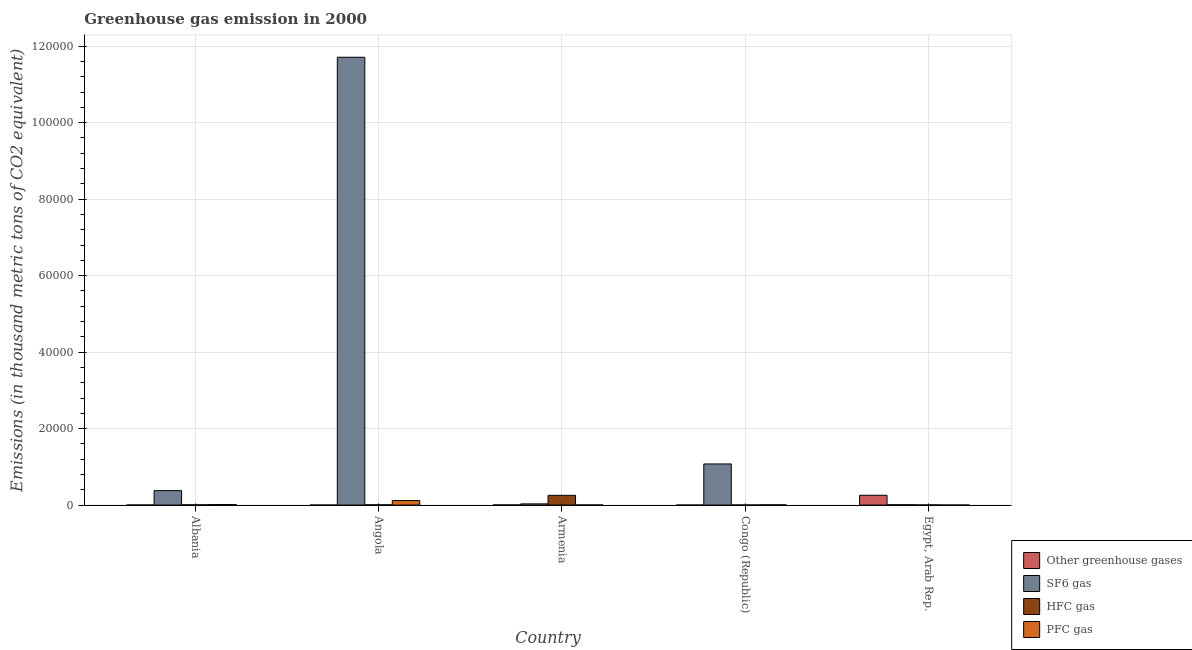Are the number of bars per tick equal to the number of legend labels?
Offer a very short reply. Yes. Are the number of bars on each tick of the X-axis equal?
Offer a terse response. Yes. How many bars are there on the 1st tick from the left?
Your answer should be very brief. 4. What is the label of the 5th group of bars from the left?
Your response must be concise. Egypt, Arab Rep. In how many cases, is the number of bars for a given country not equal to the number of legend labels?
Give a very brief answer. 0. What is the emission of sf6 gas in Armenia?
Offer a very short reply. 311.4. Across all countries, what is the maximum emission of pfc gas?
Provide a succinct answer. 1181.4. Across all countries, what is the minimum emission of sf6 gas?
Offer a terse response. 81.4. In which country was the emission of hfc gas maximum?
Your answer should be compact. Armenia. In which country was the emission of sf6 gas minimum?
Give a very brief answer. Egypt, Arab Rep. What is the total emission of greenhouse gases in the graph?
Offer a very short reply. 2624.6. What is the difference between the emission of greenhouse gases in Angola and that in Egypt, Arab Rep.?
Offer a very short reply. -2564.9. What is the difference between the emission of greenhouse gases in Armenia and the emission of sf6 gas in Egypt, Arab Rep.?
Provide a short and direct response. -39.4. What is the average emission of greenhouse gases per country?
Keep it short and to the point. 524.92. What is the difference between the emission of greenhouse gases and emission of pfc gas in Armenia?
Your answer should be compact. 9.2. What is the ratio of the emission of hfc gas in Albania to that in Armenia?
Keep it short and to the point. 0.02. What is the difference between the highest and the second highest emission of pfc gas?
Offer a very short reply. 1059.6. What is the difference between the highest and the lowest emission of sf6 gas?
Ensure brevity in your answer.  1.17e+05. Is the sum of the emission of hfc gas in Angola and Congo (Republic) greater than the maximum emission of sf6 gas across all countries?
Keep it short and to the point. No. What does the 4th bar from the left in Angola represents?
Make the answer very short. PFC gas. What does the 4th bar from the right in Congo (Republic) represents?
Make the answer very short. Other greenhouse gases. What is the difference between two consecutive major ticks on the Y-axis?
Offer a very short reply. 2.00e+04. Does the graph contain grids?
Your answer should be very brief. Yes. How many legend labels are there?
Make the answer very short. 4. What is the title of the graph?
Keep it short and to the point. Greenhouse gas emission in 2000. Does "Plant species" appear as one of the legend labels in the graph?
Keep it short and to the point. No. What is the label or title of the Y-axis?
Give a very brief answer. Emissions (in thousand metric tons of CO2 equivalent). What is the Emissions (in thousand metric tons of CO2 equivalent) of SF6 gas in Albania?
Provide a short and direct response. 3781.9. What is the Emissions (in thousand metric tons of CO2 equivalent) of HFC gas in Albania?
Give a very brief answer. 60.5. What is the Emissions (in thousand metric tons of CO2 equivalent) in PFC gas in Albania?
Your answer should be compact. 121.8. What is the Emissions (in thousand metric tons of CO2 equivalent) in SF6 gas in Angola?
Provide a short and direct response. 1.17e+05. What is the Emissions (in thousand metric tons of CO2 equivalent) of PFC gas in Angola?
Give a very brief answer. 1181.4. What is the Emissions (in thousand metric tons of CO2 equivalent) in Other greenhouse gases in Armenia?
Offer a very short reply. 42. What is the Emissions (in thousand metric tons of CO2 equivalent) in SF6 gas in Armenia?
Offer a very short reply. 311.4. What is the Emissions (in thousand metric tons of CO2 equivalent) of HFC gas in Armenia?
Offer a terse response. 2545.7. What is the Emissions (in thousand metric tons of CO2 equivalent) of PFC gas in Armenia?
Provide a short and direct response. 32.8. What is the Emissions (in thousand metric tons of CO2 equivalent) in Other greenhouse gases in Congo (Republic)?
Provide a succinct answer. 0.8. What is the Emissions (in thousand metric tons of CO2 equivalent) in SF6 gas in Congo (Republic)?
Make the answer very short. 1.08e+04. What is the Emissions (in thousand metric tons of CO2 equivalent) of HFC gas in Congo (Republic)?
Offer a very short reply. 25.2. What is the Emissions (in thousand metric tons of CO2 equivalent) of Other greenhouse gases in Egypt, Arab Rep.?
Keep it short and to the point. 2565.6. What is the Emissions (in thousand metric tons of CO2 equivalent) of SF6 gas in Egypt, Arab Rep.?
Offer a terse response. 81.4. What is the Emissions (in thousand metric tons of CO2 equivalent) of HFC gas in Egypt, Arab Rep.?
Your answer should be very brief. 41.4. What is the Emissions (in thousand metric tons of CO2 equivalent) in PFC gas in Egypt, Arab Rep.?
Make the answer very short. 3.5. Across all countries, what is the maximum Emissions (in thousand metric tons of CO2 equivalent) in Other greenhouse gases?
Ensure brevity in your answer.  2565.6. Across all countries, what is the maximum Emissions (in thousand metric tons of CO2 equivalent) in SF6 gas?
Offer a terse response. 1.17e+05. Across all countries, what is the maximum Emissions (in thousand metric tons of CO2 equivalent) of HFC gas?
Offer a terse response. 2545.7. Across all countries, what is the maximum Emissions (in thousand metric tons of CO2 equivalent) in PFC gas?
Keep it short and to the point. 1181.4. Across all countries, what is the minimum Emissions (in thousand metric tons of CO2 equivalent) of SF6 gas?
Offer a very short reply. 81.4. Across all countries, what is the minimum Emissions (in thousand metric tons of CO2 equivalent) of HFC gas?
Provide a succinct answer. 25.2. What is the total Emissions (in thousand metric tons of CO2 equivalent) in Other greenhouse gases in the graph?
Keep it short and to the point. 2624.6. What is the total Emissions (in thousand metric tons of CO2 equivalent) in SF6 gas in the graph?
Provide a succinct answer. 1.32e+05. What is the total Emissions (in thousand metric tons of CO2 equivalent) of HFC gas in the graph?
Provide a succinct answer. 2735.8. What is the total Emissions (in thousand metric tons of CO2 equivalent) in PFC gas in the graph?
Make the answer very short. 1402.5. What is the difference between the Emissions (in thousand metric tons of CO2 equivalent) of SF6 gas in Albania and that in Angola?
Your answer should be very brief. -1.13e+05. What is the difference between the Emissions (in thousand metric tons of CO2 equivalent) in PFC gas in Albania and that in Angola?
Make the answer very short. -1059.6. What is the difference between the Emissions (in thousand metric tons of CO2 equivalent) of Other greenhouse gases in Albania and that in Armenia?
Give a very brief answer. -26.5. What is the difference between the Emissions (in thousand metric tons of CO2 equivalent) in SF6 gas in Albania and that in Armenia?
Offer a very short reply. 3470.5. What is the difference between the Emissions (in thousand metric tons of CO2 equivalent) of HFC gas in Albania and that in Armenia?
Keep it short and to the point. -2485.2. What is the difference between the Emissions (in thousand metric tons of CO2 equivalent) of PFC gas in Albania and that in Armenia?
Keep it short and to the point. 89. What is the difference between the Emissions (in thousand metric tons of CO2 equivalent) of SF6 gas in Albania and that in Congo (Republic)?
Offer a very short reply. -6971.7. What is the difference between the Emissions (in thousand metric tons of CO2 equivalent) of HFC gas in Albania and that in Congo (Republic)?
Offer a terse response. 35.3. What is the difference between the Emissions (in thousand metric tons of CO2 equivalent) of PFC gas in Albania and that in Congo (Republic)?
Offer a terse response. 58.8. What is the difference between the Emissions (in thousand metric tons of CO2 equivalent) in Other greenhouse gases in Albania and that in Egypt, Arab Rep.?
Provide a succinct answer. -2550.1. What is the difference between the Emissions (in thousand metric tons of CO2 equivalent) of SF6 gas in Albania and that in Egypt, Arab Rep.?
Keep it short and to the point. 3700.5. What is the difference between the Emissions (in thousand metric tons of CO2 equivalent) of HFC gas in Albania and that in Egypt, Arab Rep.?
Offer a terse response. 19.1. What is the difference between the Emissions (in thousand metric tons of CO2 equivalent) of PFC gas in Albania and that in Egypt, Arab Rep.?
Your answer should be very brief. 118.3. What is the difference between the Emissions (in thousand metric tons of CO2 equivalent) of Other greenhouse gases in Angola and that in Armenia?
Give a very brief answer. -41.3. What is the difference between the Emissions (in thousand metric tons of CO2 equivalent) of SF6 gas in Angola and that in Armenia?
Your answer should be very brief. 1.17e+05. What is the difference between the Emissions (in thousand metric tons of CO2 equivalent) in HFC gas in Angola and that in Armenia?
Provide a short and direct response. -2482.7. What is the difference between the Emissions (in thousand metric tons of CO2 equivalent) of PFC gas in Angola and that in Armenia?
Your answer should be compact. 1148.6. What is the difference between the Emissions (in thousand metric tons of CO2 equivalent) of Other greenhouse gases in Angola and that in Congo (Republic)?
Offer a terse response. -0.1. What is the difference between the Emissions (in thousand metric tons of CO2 equivalent) in SF6 gas in Angola and that in Congo (Republic)?
Make the answer very short. 1.06e+05. What is the difference between the Emissions (in thousand metric tons of CO2 equivalent) of HFC gas in Angola and that in Congo (Republic)?
Keep it short and to the point. 37.8. What is the difference between the Emissions (in thousand metric tons of CO2 equivalent) in PFC gas in Angola and that in Congo (Republic)?
Ensure brevity in your answer.  1118.4. What is the difference between the Emissions (in thousand metric tons of CO2 equivalent) of Other greenhouse gases in Angola and that in Egypt, Arab Rep.?
Keep it short and to the point. -2564.9. What is the difference between the Emissions (in thousand metric tons of CO2 equivalent) in SF6 gas in Angola and that in Egypt, Arab Rep.?
Offer a very short reply. 1.17e+05. What is the difference between the Emissions (in thousand metric tons of CO2 equivalent) in HFC gas in Angola and that in Egypt, Arab Rep.?
Provide a short and direct response. 21.6. What is the difference between the Emissions (in thousand metric tons of CO2 equivalent) in PFC gas in Angola and that in Egypt, Arab Rep.?
Your answer should be compact. 1177.9. What is the difference between the Emissions (in thousand metric tons of CO2 equivalent) in Other greenhouse gases in Armenia and that in Congo (Republic)?
Keep it short and to the point. 41.2. What is the difference between the Emissions (in thousand metric tons of CO2 equivalent) of SF6 gas in Armenia and that in Congo (Republic)?
Your answer should be compact. -1.04e+04. What is the difference between the Emissions (in thousand metric tons of CO2 equivalent) of HFC gas in Armenia and that in Congo (Republic)?
Ensure brevity in your answer.  2520.5. What is the difference between the Emissions (in thousand metric tons of CO2 equivalent) of PFC gas in Armenia and that in Congo (Republic)?
Give a very brief answer. -30.2. What is the difference between the Emissions (in thousand metric tons of CO2 equivalent) of Other greenhouse gases in Armenia and that in Egypt, Arab Rep.?
Make the answer very short. -2523.6. What is the difference between the Emissions (in thousand metric tons of CO2 equivalent) in SF6 gas in Armenia and that in Egypt, Arab Rep.?
Your answer should be compact. 230. What is the difference between the Emissions (in thousand metric tons of CO2 equivalent) of HFC gas in Armenia and that in Egypt, Arab Rep.?
Ensure brevity in your answer.  2504.3. What is the difference between the Emissions (in thousand metric tons of CO2 equivalent) in PFC gas in Armenia and that in Egypt, Arab Rep.?
Provide a succinct answer. 29.3. What is the difference between the Emissions (in thousand metric tons of CO2 equivalent) in Other greenhouse gases in Congo (Republic) and that in Egypt, Arab Rep.?
Provide a short and direct response. -2564.8. What is the difference between the Emissions (in thousand metric tons of CO2 equivalent) of SF6 gas in Congo (Republic) and that in Egypt, Arab Rep.?
Keep it short and to the point. 1.07e+04. What is the difference between the Emissions (in thousand metric tons of CO2 equivalent) of HFC gas in Congo (Republic) and that in Egypt, Arab Rep.?
Offer a very short reply. -16.2. What is the difference between the Emissions (in thousand metric tons of CO2 equivalent) in PFC gas in Congo (Republic) and that in Egypt, Arab Rep.?
Make the answer very short. 59.5. What is the difference between the Emissions (in thousand metric tons of CO2 equivalent) of Other greenhouse gases in Albania and the Emissions (in thousand metric tons of CO2 equivalent) of SF6 gas in Angola?
Your answer should be compact. -1.17e+05. What is the difference between the Emissions (in thousand metric tons of CO2 equivalent) in Other greenhouse gases in Albania and the Emissions (in thousand metric tons of CO2 equivalent) in HFC gas in Angola?
Make the answer very short. -47.5. What is the difference between the Emissions (in thousand metric tons of CO2 equivalent) of Other greenhouse gases in Albania and the Emissions (in thousand metric tons of CO2 equivalent) of PFC gas in Angola?
Your answer should be very brief. -1165.9. What is the difference between the Emissions (in thousand metric tons of CO2 equivalent) of SF6 gas in Albania and the Emissions (in thousand metric tons of CO2 equivalent) of HFC gas in Angola?
Provide a short and direct response. 3718.9. What is the difference between the Emissions (in thousand metric tons of CO2 equivalent) of SF6 gas in Albania and the Emissions (in thousand metric tons of CO2 equivalent) of PFC gas in Angola?
Provide a short and direct response. 2600.5. What is the difference between the Emissions (in thousand metric tons of CO2 equivalent) of HFC gas in Albania and the Emissions (in thousand metric tons of CO2 equivalent) of PFC gas in Angola?
Provide a short and direct response. -1120.9. What is the difference between the Emissions (in thousand metric tons of CO2 equivalent) of Other greenhouse gases in Albania and the Emissions (in thousand metric tons of CO2 equivalent) of SF6 gas in Armenia?
Your answer should be compact. -295.9. What is the difference between the Emissions (in thousand metric tons of CO2 equivalent) of Other greenhouse gases in Albania and the Emissions (in thousand metric tons of CO2 equivalent) of HFC gas in Armenia?
Give a very brief answer. -2530.2. What is the difference between the Emissions (in thousand metric tons of CO2 equivalent) in Other greenhouse gases in Albania and the Emissions (in thousand metric tons of CO2 equivalent) in PFC gas in Armenia?
Provide a short and direct response. -17.3. What is the difference between the Emissions (in thousand metric tons of CO2 equivalent) of SF6 gas in Albania and the Emissions (in thousand metric tons of CO2 equivalent) of HFC gas in Armenia?
Your answer should be compact. 1236.2. What is the difference between the Emissions (in thousand metric tons of CO2 equivalent) of SF6 gas in Albania and the Emissions (in thousand metric tons of CO2 equivalent) of PFC gas in Armenia?
Provide a short and direct response. 3749.1. What is the difference between the Emissions (in thousand metric tons of CO2 equivalent) in HFC gas in Albania and the Emissions (in thousand metric tons of CO2 equivalent) in PFC gas in Armenia?
Offer a terse response. 27.7. What is the difference between the Emissions (in thousand metric tons of CO2 equivalent) of Other greenhouse gases in Albania and the Emissions (in thousand metric tons of CO2 equivalent) of SF6 gas in Congo (Republic)?
Your answer should be compact. -1.07e+04. What is the difference between the Emissions (in thousand metric tons of CO2 equivalent) in Other greenhouse gases in Albania and the Emissions (in thousand metric tons of CO2 equivalent) in PFC gas in Congo (Republic)?
Provide a succinct answer. -47.5. What is the difference between the Emissions (in thousand metric tons of CO2 equivalent) of SF6 gas in Albania and the Emissions (in thousand metric tons of CO2 equivalent) of HFC gas in Congo (Republic)?
Provide a short and direct response. 3756.7. What is the difference between the Emissions (in thousand metric tons of CO2 equivalent) in SF6 gas in Albania and the Emissions (in thousand metric tons of CO2 equivalent) in PFC gas in Congo (Republic)?
Make the answer very short. 3718.9. What is the difference between the Emissions (in thousand metric tons of CO2 equivalent) in Other greenhouse gases in Albania and the Emissions (in thousand metric tons of CO2 equivalent) in SF6 gas in Egypt, Arab Rep.?
Make the answer very short. -65.9. What is the difference between the Emissions (in thousand metric tons of CO2 equivalent) of Other greenhouse gases in Albania and the Emissions (in thousand metric tons of CO2 equivalent) of HFC gas in Egypt, Arab Rep.?
Offer a terse response. -25.9. What is the difference between the Emissions (in thousand metric tons of CO2 equivalent) of SF6 gas in Albania and the Emissions (in thousand metric tons of CO2 equivalent) of HFC gas in Egypt, Arab Rep.?
Your answer should be very brief. 3740.5. What is the difference between the Emissions (in thousand metric tons of CO2 equivalent) in SF6 gas in Albania and the Emissions (in thousand metric tons of CO2 equivalent) in PFC gas in Egypt, Arab Rep.?
Provide a succinct answer. 3778.4. What is the difference between the Emissions (in thousand metric tons of CO2 equivalent) of HFC gas in Albania and the Emissions (in thousand metric tons of CO2 equivalent) of PFC gas in Egypt, Arab Rep.?
Provide a short and direct response. 57. What is the difference between the Emissions (in thousand metric tons of CO2 equivalent) of Other greenhouse gases in Angola and the Emissions (in thousand metric tons of CO2 equivalent) of SF6 gas in Armenia?
Give a very brief answer. -310.7. What is the difference between the Emissions (in thousand metric tons of CO2 equivalent) in Other greenhouse gases in Angola and the Emissions (in thousand metric tons of CO2 equivalent) in HFC gas in Armenia?
Make the answer very short. -2545. What is the difference between the Emissions (in thousand metric tons of CO2 equivalent) of Other greenhouse gases in Angola and the Emissions (in thousand metric tons of CO2 equivalent) of PFC gas in Armenia?
Give a very brief answer. -32.1. What is the difference between the Emissions (in thousand metric tons of CO2 equivalent) in SF6 gas in Angola and the Emissions (in thousand metric tons of CO2 equivalent) in HFC gas in Armenia?
Your response must be concise. 1.15e+05. What is the difference between the Emissions (in thousand metric tons of CO2 equivalent) of SF6 gas in Angola and the Emissions (in thousand metric tons of CO2 equivalent) of PFC gas in Armenia?
Your response must be concise. 1.17e+05. What is the difference between the Emissions (in thousand metric tons of CO2 equivalent) in HFC gas in Angola and the Emissions (in thousand metric tons of CO2 equivalent) in PFC gas in Armenia?
Your response must be concise. 30.2. What is the difference between the Emissions (in thousand metric tons of CO2 equivalent) of Other greenhouse gases in Angola and the Emissions (in thousand metric tons of CO2 equivalent) of SF6 gas in Congo (Republic)?
Ensure brevity in your answer.  -1.08e+04. What is the difference between the Emissions (in thousand metric tons of CO2 equivalent) in Other greenhouse gases in Angola and the Emissions (in thousand metric tons of CO2 equivalent) in HFC gas in Congo (Republic)?
Keep it short and to the point. -24.5. What is the difference between the Emissions (in thousand metric tons of CO2 equivalent) in Other greenhouse gases in Angola and the Emissions (in thousand metric tons of CO2 equivalent) in PFC gas in Congo (Republic)?
Make the answer very short. -62.3. What is the difference between the Emissions (in thousand metric tons of CO2 equivalent) in SF6 gas in Angola and the Emissions (in thousand metric tons of CO2 equivalent) in HFC gas in Congo (Republic)?
Ensure brevity in your answer.  1.17e+05. What is the difference between the Emissions (in thousand metric tons of CO2 equivalent) of SF6 gas in Angola and the Emissions (in thousand metric tons of CO2 equivalent) of PFC gas in Congo (Republic)?
Offer a terse response. 1.17e+05. What is the difference between the Emissions (in thousand metric tons of CO2 equivalent) of Other greenhouse gases in Angola and the Emissions (in thousand metric tons of CO2 equivalent) of SF6 gas in Egypt, Arab Rep.?
Ensure brevity in your answer.  -80.7. What is the difference between the Emissions (in thousand metric tons of CO2 equivalent) in Other greenhouse gases in Angola and the Emissions (in thousand metric tons of CO2 equivalent) in HFC gas in Egypt, Arab Rep.?
Your response must be concise. -40.7. What is the difference between the Emissions (in thousand metric tons of CO2 equivalent) of Other greenhouse gases in Angola and the Emissions (in thousand metric tons of CO2 equivalent) of PFC gas in Egypt, Arab Rep.?
Your response must be concise. -2.8. What is the difference between the Emissions (in thousand metric tons of CO2 equivalent) in SF6 gas in Angola and the Emissions (in thousand metric tons of CO2 equivalent) in HFC gas in Egypt, Arab Rep.?
Make the answer very short. 1.17e+05. What is the difference between the Emissions (in thousand metric tons of CO2 equivalent) of SF6 gas in Angola and the Emissions (in thousand metric tons of CO2 equivalent) of PFC gas in Egypt, Arab Rep.?
Your answer should be very brief. 1.17e+05. What is the difference between the Emissions (in thousand metric tons of CO2 equivalent) of HFC gas in Angola and the Emissions (in thousand metric tons of CO2 equivalent) of PFC gas in Egypt, Arab Rep.?
Ensure brevity in your answer.  59.5. What is the difference between the Emissions (in thousand metric tons of CO2 equivalent) of Other greenhouse gases in Armenia and the Emissions (in thousand metric tons of CO2 equivalent) of SF6 gas in Congo (Republic)?
Offer a terse response. -1.07e+04. What is the difference between the Emissions (in thousand metric tons of CO2 equivalent) in SF6 gas in Armenia and the Emissions (in thousand metric tons of CO2 equivalent) in HFC gas in Congo (Republic)?
Offer a very short reply. 286.2. What is the difference between the Emissions (in thousand metric tons of CO2 equivalent) in SF6 gas in Armenia and the Emissions (in thousand metric tons of CO2 equivalent) in PFC gas in Congo (Republic)?
Offer a very short reply. 248.4. What is the difference between the Emissions (in thousand metric tons of CO2 equivalent) in HFC gas in Armenia and the Emissions (in thousand metric tons of CO2 equivalent) in PFC gas in Congo (Republic)?
Give a very brief answer. 2482.7. What is the difference between the Emissions (in thousand metric tons of CO2 equivalent) in Other greenhouse gases in Armenia and the Emissions (in thousand metric tons of CO2 equivalent) in SF6 gas in Egypt, Arab Rep.?
Your response must be concise. -39.4. What is the difference between the Emissions (in thousand metric tons of CO2 equivalent) of Other greenhouse gases in Armenia and the Emissions (in thousand metric tons of CO2 equivalent) of HFC gas in Egypt, Arab Rep.?
Give a very brief answer. 0.6. What is the difference between the Emissions (in thousand metric tons of CO2 equivalent) in Other greenhouse gases in Armenia and the Emissions (in thousand metric tons of CO2 equivalent) in PFC gas in Egypt, Arab Rep.?
Provide a succinct answer. 38.5. What is the difference between the Emissions (in thousand metric tons of CO2 equivalent) of SF6 gas in Armenia and the Emissions (in thousand metric tons of CO2 equivalent) of HFC gas in Egypt, Arab Rep.?
Provide a short and direct response. 270. What is the difference between the Emissions (in thousand metric tons of CO2 equivalent) in SF6 gas in Armenia and the Emissions (in thousand metric tons of CO2 equivalent) in PFC gas in Egypt, Arab Rep.?
Your answer should be very brief. 307.9. What is the difference between the Emissions (in thousand metric tons of CO2 equivalent) of HFC gas in Armenia and the Emissions (in thousand metric tons of CO2 equivalent) of PFC gas in Egypt, Arab Rep.?
Make the answer very short. 2542.2. What is the difference between the Emissions (in thousand metric tons of CO2 equivalent) of Other greenhouse gases in Congo (Republic) and the Emissions (in thousand metric tons of CO2 equivalent) of SF6 gas in Egypt, Arab Rep.?
Ensure brevity in your answer.  -80.6. What is the difference between the Emissions (in thousand metric tons of CO2 equivalent) of Other greenhouse gases in Congo (Republic) and the Emissions (in thousand metric tons of CO2 equivalent) of HFC gas in Egypt, Arab Rep.?
Ensure brevity in your answer.  -40.6. What is the difference between the Emissions (in thousand metric tons of CO2 equivalent) of SF6 gas in Congo (Republic) and the Emissions (in thousand metric tons of CO2 equivalent) of HFC gas in Egypt, Arab Rep.?
Your answer should be compact. 1.07e+04. What is the difference between the Emissions (in thousand metric tons of CO2 equivalent) in SF6 gas in Congo (Republic) and the Emissions (in thousand metric tons of CO2 equivalent) in PFC gas in Egypt, Arab Rep.?
Offer a very short reply. 1.08e+04. What is the difference between the Emissions (in thousand metric tons of CO2 equivalent) in HFC gas in Congo (Republic) and the Emissions (in thousand metric tons of CO2 equivalent) in PFC gas in Egypt, Arab Rep.?
Your response must be concise. 21.7. What is the average Emissions (in thousand metric tons of CO2 equivalent) of Other greenhouse gases per country?
Your response must be concise. 524.92. What is the average Emissions (in thousand metric tons of CO2 equivalent) in SF6 gas per country?
Provide a short and direct response. 2.64e+04. What is the average Emissions (in thousand metric tons of CO2 equivalent) in HFC gas per country?
Provide a short and direct response. 547.16. What is the average Emissions (in thousand metric tons of CO2 equivalent) in PFC gas per country?
Provide a short and direct response. 280.5. What is the difference between the Emissions (in thousand metric tons of CO2 equivalent) in Other greenhouse gases and Emissions (in thousand metric tons of CO2 equivalent) in SF6 gas in Albania?
Your answer should be very brief. -3766.4. What is the difference between the Emissions (in thousand metric tons of CO2 equivalent) of Other greenhouse gases and Emissions (in thousand metric tons of CO2 equivalent) of HFC gas in Albania?
Keep it short and to the point. -45. What is the difference between the Emissions (in thousand metric tons of CO2 equivalent) in Other greenhouse gases and Emissions (in thousand metric tons of CO2 equivalent) in PFC gas in Albania?
Provide a succinct answer. -106.3. What is the difference between the Emissions (in thousand metric tons of CO2 equivalent) of SF6 gas and Emissions (in thousand metric tons of CO2 equivalent) of HFC gas in Albania?
Give a very brief answer. 3721.4. What is the difference between the Emissions (in thousand metric tons of CO2 equivalent) of SF6 gas and Emissions (in thousand metric tons of CO2 equivalent) of PFC gas in Albania?
Make the answer very short. 3660.1. What is the difference between the Emissions (in thousand metric tons of CO2 equivalent) of HFC gas and Emissions (in thousand metric tons of CO2 equivalent) of PFC gas in Albania?
Offer a terse response. -61.3. What is the difference between the Emissions (in thousand metric tons of CO2 equivalent) of Other greenhouse gases and Emissions (in thousand metric tons of CO2 equivalent) of SF6 gas in Angola?
Your answer should be compact. -1.17e+05. What is the difference between the Emissions (in thousand metric tons of CO2 equivalent) of Other greenhouse gases and Emissions (in thousand metric tons of CO2 equivalent) of HFC gas in Angola?
Your response must be concise. -62.3. What is the difference between the Emissions (in thousand metric tons of CO2 equivalent) in Other greenhouse gases and Emissions (in thousand metric tons of CO2 equivalent) in PFC gas in Angola?
Your response must be concise. -1180.7. What is the difference between the Emissions (in thousand metric tons of CO2 equivalent) in SF6 gas and Emissions (in thousand metric tons of CO2 equivalent) in HFC gas in Angola?
Offer a terse response. 1.17e+05. What is the difference between the Emissions (in thousand metric tons of CO2 equivalent) of SF6 gas and Emissions (in thousand metric tons of CO2 equivalent) of PFC gas in Angola?
Your response must be concise. 1.16e+05. What is the difference between the Emissions (in thousand metric tons of CO2 equivalent) of HFC gas and Emissions (in thousand metric tons of CO2 equivalent) of PFC gas in Angola?
Ensure brevity in your answer.  -1118.4. What is the difference between the Emissions (in thousand metric tons of CO2 equivalent) in Other greenhouse gases and Emissions (in thousand metric tons of CO2 equivalent) in SF6 gas in Armenia?
Provide a succinct answer. -269.4. What is the difference between the Emissions (in thousand metric tons of CO2 equivalent) of Other greenhouse gases and Emissions (in thousand metric tons of CO2 equivalent) of HFC gas in Armenia?
Your response must be concise. -2503.7. What is the difference between the Emissions (in thousand metric tons of CO2 equivalent) of SF6 gas and Emissions (in thousand metric tons of CO2 equivalent) of HFC gas in Armenia?
Keep it short and to the point. -2234.3. What is the difference between the Emissions (in thousand metric tons of CO2 equivalent) of SF6 gas and Emissions (in thousand metric tons of CO2 equivalent) of PFC gas in Armenia?
Your answer should be very brief. 278.6. What is the difference between the Emissions (in thousand metric tons of CO2 equivalent) of HFC gas and Emissions (in thousand metric tons of CO2 equivalent) of PFC gas in Armenia?
Your answer should be very brief. 2512.9. What is the difference between the Emissions (in thousand metric tons of CO2 equivalent) in Other greenhouse gases and Emissions (in thousand metric tons of CO2 equivalent) in SF6 gas in Congo (Republic)?
Your response must be concise. -1.08e+04. What is the difference between the Emissions (in thousand metric tons of CO2 equivalent) of Other greenhouse gases and Emissions (in thousand metric tons of CO2 equivalent) of HFC gas in Congo (Republic)?
Provide a succinct answer. -24.4. What is the difference between the Emissions (in thousand metric tons of CO2 equivalent) of Other greenhouse gases and Emissions (in thousand metric tons of CO2 equivalent) of PFC gas in Congo (Republic)?
Make the answer very short. -62.2. What is the difference between the Emissions (in thousand metric tons of CO2 equivalent) in SF6 gas and Emissions (in thousand metric tons of CO2 equivalent) in HFC gas in Congo (Republic)?
Your answer should be very brief. 1.07e+04. What is the difference between the Emissions (in thousand metric tons of CO2 equivalent) in SF6 gas and Emissions (in thousand metric tons of CO2 equivalent) in PFC gas in Congo (Republic)?
Your answer should be very brief. 1.07e+04. What is the difference between the Emissions (in thousand metric tons of CO2 equivalent) in HFC gas and Emissions (in thousand metric tons of CO2 equivalent) in PFC gas in Congo (Republic)?
Keep it short and to the point. -37.8. What is the difference between the Emissions (in thousand metric tons of CO2 equivalent) in Other greenhouse gases and Emissions (in thousand metric tons of CO2 equivalent) in SF6 gas in Egypt, Arab Rep.?
Your answer should be very brief. 2484.2. What is the difference between the Emissions (in thousand metric tons of CO2 equivalent) in Other greenhouse gases and Emissions (in thousand metric tons of CO2 equivalent) in HFC gas in Egypt, Arab Rep.?
Ensure brevity in your answer.  2524.2. What is the difference between the Emissions (in thousand metric tons of CO2 equivalent) of Other greenhouse gases and Emissions (in thousand metric tons of CO2 equivalent) of PFC gas in Egypt, Arab Rep.?
Your answer should be very brief. 2562.1. What is the difference between the Emissions (in thousand metric tons of CO2 equivalent) of SF6 gas and Emissions (in thousand metric tons of CO2 equivalent) of PFC gas in Egypt, Arab Rep.?
Your answer should be compact. 77.9. What is the difference between the Emissions (in thousand metric tons of CO2 equivalent) in HFC gas and Emissions (in thousand metric tons of CO2 equivalent) in PFC gas in Egypt, Arab Rep.?
Your response must be concise. 37.9. What is the ratio of the Emissions (in thousand metric tons of CO2 equivalent) in Other greenhouse gases in Albania to that in Angola?
Provide a succinct answer. 22.14. What is the ratio of the Emissions (in thousand metric tons of CO2 equivalent) of SF6 gas in Albania to that in Angola?
Provide a short and direct response. 0.03. What is the ratio of the Emissions (in thousand metric tons of CO2 equivalent) in HFC gas in Albania to that in Angola?
Provide a short and direct response. 0.96. What is the ratio of the Emissions (in thousand metric tons of CO2 equivalent) in PFC gas in Albania to that in Angola?
Ensure brevity in your answer.  0.1. What is the ratio of the Emissions (in thousand metric tons of CO2 equivalent) of Other greenhouse gases in Albania to that in Armenia?
Your answer should be compact. 0.37. What is the ratio of the Emissions (in thousand metric tons of CO2 equivalent) in SF6 gas in Albania to that in Armenia?
Your response must be concise. 12.14. What is the ratio of the Emissions (in thousand metric tons of CO2 equivalent) in HFC gas in Albania to that in Armenia?
Your response must be concise. 0.02. What is the ratio of the Emissions (in thousand metric tons of CO2 equivalent) of PFC gas in Albania to that in Armenia?
Make the answer very short. 3.71. What is the ratio of the Emissions (in thousand metric tons of CO2 equivalent) of Other greenhouse gases in Albania to that in Congo (Republic)?
Give a very brief answer. 19.38. What is the ratio of the Emissions (in thousand metric tons of CO2 equivalent) of SF6 gas in Albania to that in Congo (Republic)?
Provide a succinct answer. 0.35. What is the ratio of the Emissions (in thousand metric tons of CO2 equivalent) in HFC gas in Albania to that in Congo (Republic)?
Ensure brevity in your answer.  2.4. What is the ratio of the Emissions (in thousand metric tons of CO2 equivalent) of PFC gas in Albania to that in Congo (Republic)?
Ensure brevity in your answer.  1.93. What is the ratio of the Emissions (in thousand metric tons of CO2 equivalent) of Other greenhouse gases in Albania to that in Egypt, Arab Rep.?
Your answer should be very brief. 0.01. What is the ratio of the Emissions (in thousand metric tons of CO2 equivalent) in SF6 gas in Albania to that in Egypt, Arab Rep.?
Offer a very short reply. 46.46. What is the ratio of the Emissions (in thousand metric tons of CO2 equivalent) in HFC gas in Albania to that in Egypt, Arab Rep.?
Your answer should be compact. 1.46. What is the ratio of the Emissions (in thousand metric tons of CO2 equivalent) of PFC gas in Albania to that in Egypt, Arab Rep.?
Provide a succinct answer. 34.8. What is the ratio of the Emissions (in thousand metric tons of CO2 equivalent) in Other greenhouse gases in Angola to that in Armenia?
Your response must be concise. 0.02. What is the ratio of the Emissions (in thousand metric tons of CO2 equivalent) in SF6 gas in Angola to that in Armenia?
Keep it short and to the point. 376.06. What is the ratio of the Emissions (in thousand metric tons of CO2 equivalent) of HFC gas in Angola to that in Armenia?
Make the answer very short. 0.02. What is the ratio of the Emissions (in thousand metric tons of CO2 equivalent) in PFC gas in Angola to that in Armenia?
Offer a very short reply. 36.02. What is the ratio of the Emissions (in thousand metric tons of CO2 equivalent) in SF6 gas in Angola to that in Congo (Republic)?
Offer a terse response. 10.89. What is the ratio of the Emissions (in thousand metric tons of CO2 equivalent) in HFC gas in Angola to that in Congo (Republic)?
Give a very brief answer. 2.5. What is the ratio of the Emissions (in thousand metric tons of CO2 equivalent) in PFC gas in Angola to that in Congo (Republic)?
Your answer should be very brief. 18.75. What is the ratio of the Emissions (in thousand metric tons of CO2 equivalent) in SF6 gas in Angola to that in Egypt, Arab Rep.?
Ensure brevity in your answer.  1438.62. What is the ratio of the Emissions (in thousand metric tons of CO2 equivalent) in HFC gas in Angola to that in Egypt, Arab Rep.?
Your answer should be compact. 1.52. What is the ratio of the Emissions (in thousand metric tons of CO2 equivalent) in PFC gas in Angola to that in Egypt, Arab Rep.?
Your answer should be compact. 337.54. What is the ratio of the Emissions (in thousand metric tons of CO2 equivalent) in Other greenhouse gases in Armenia to that in Congo (Republic)?
Provide a succinct answer. 52.5. What is the ratio of the Emissions (in thousand metric tons of CO2 equivalent) in SF6 gas in Armenia to that in Congo (Republic)?
Provide a succinct answer. 0.03. What is the ratio of the Emissions (in thousand metric tons of CO2 equivalent) of HFC gas in Armenia to that in Congo (Republic)?
Your response must be concise. 101.02. What is the ratio of the Emissions (in thousand metric tons of CO2 equivalent) in PFC gas in Armenia to that in Congo (Republic)?
Make the answer very short. 0.52. What is the ratio of the Emissions (in thousand metric tons of CO2 equivalent) in Other greenhouse gases in Armenia to that in Egypt, Arab Rep.?
Give a very brief answer. 0.02. What is the ratio of the Emissions (in thousand metric tons of CO2 equivalent) in SF6 gas in Armenia to that in Egypt, Arab Rep.?
Make the answer very short. 3.83. What is the ratio of the Emissions (in thousand metric tons of CO2 equivalent) in HFC gas in Armenia to that in Egypt, Arab Rep.?
Your answer should be compact. 61.49. What is the ratio of the Emissions (in thousand metric tons of CO2 equivalent) of PFC gas in Armenia to that in Egypt, Arab Rep.?
Offer a terse response. 9.37. What is the ratio of the Emissions (in thousand metric tons of CO2 equivalent) in Other greenhouse gases in Congo (Republic) to that in Egypt, Arab Rep.?
Give a very brief answer. 0. What is the ratio of the Emissions (in thousand metric tons of CO2 equivalent) in SF6 gas in Congo (Republic) to that in Egypt, Arab Rep.?
Your response must be concise. 132.11. What is the ratio of the Emissions (in thousand metric tons of CO2 equivalent) of HFC gas in Congo (Republic) to that in Egypt, Arab Rep.?
Your answer should be compact. 0.61. What is the ratio of the Emissions (in thousand metric tons of CO2 equivalent) of PFC gas in Congo (Republic) to that in Egypt, Arab Rep.?
Keep it short and to the point. 18. What is the difference between the highest and the second highest Emissions (in thousand metric tons of CO2 equivalent) in Other greenhouse gases?
Keep it short and to the point. 2523.6. What is the difference between the highest and the second highest Emissions (in thousand metric tons of CO2 equivalent) in SF6 gas?
Ensure brevity in your answer.  1.06e+05. What is the difference between the highest and the second highest Emissions (in thousand metric tons of CO2 equivalent) of HFC gas?
Provide a succinct answer. 2482.7. What is the difference between the highest and the second highest Emissions (in thousand metric tons of CO2 equivalent) of PFC gas?
Offer a terse response. 1059.6. What is the difference between the highest and the lowest Emissions (in thousand metric tons of CO2 equivalent) in Other greenhouse gases?
Offer a very short reply. 2564.9. What is the difference between the highest and the lowest Emissions (in thousand metric tons of CO2 equivalent) of SF6 gas?
Provide a succinct answer. 1.17e+05. What is the difference between the highest and the lowest Emissions (in thousand metric tons of CO2 equivalent) in HFC gas?
Make the answer very short. 2520.5. What is the difference between the highest and the lowest Emissions (in thousand metric tons of CO2 equivalent) of PFC gas?
Give a very brief answer. 1177.9. 